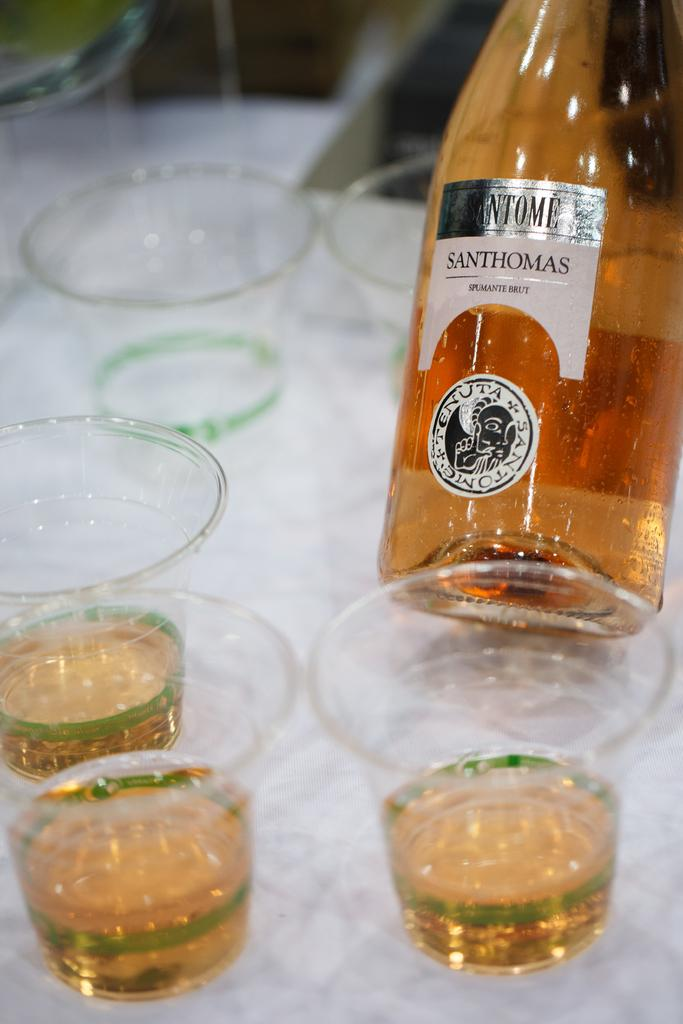What piece of furniture is present in the image? There is a table in the image. What objects are placed on the table? There are glasses and a bottle of a drink on the table. What is written on the bottle? The bottle has "Santhomas" written on it. How many glasses are filled with the drink? Three glasses are filled with the drink. Can you see a stream flowing near the table in the image? No, there is no stream visible in the image. Is there an airport in the background of the image? No, there is no airport present in the image. 